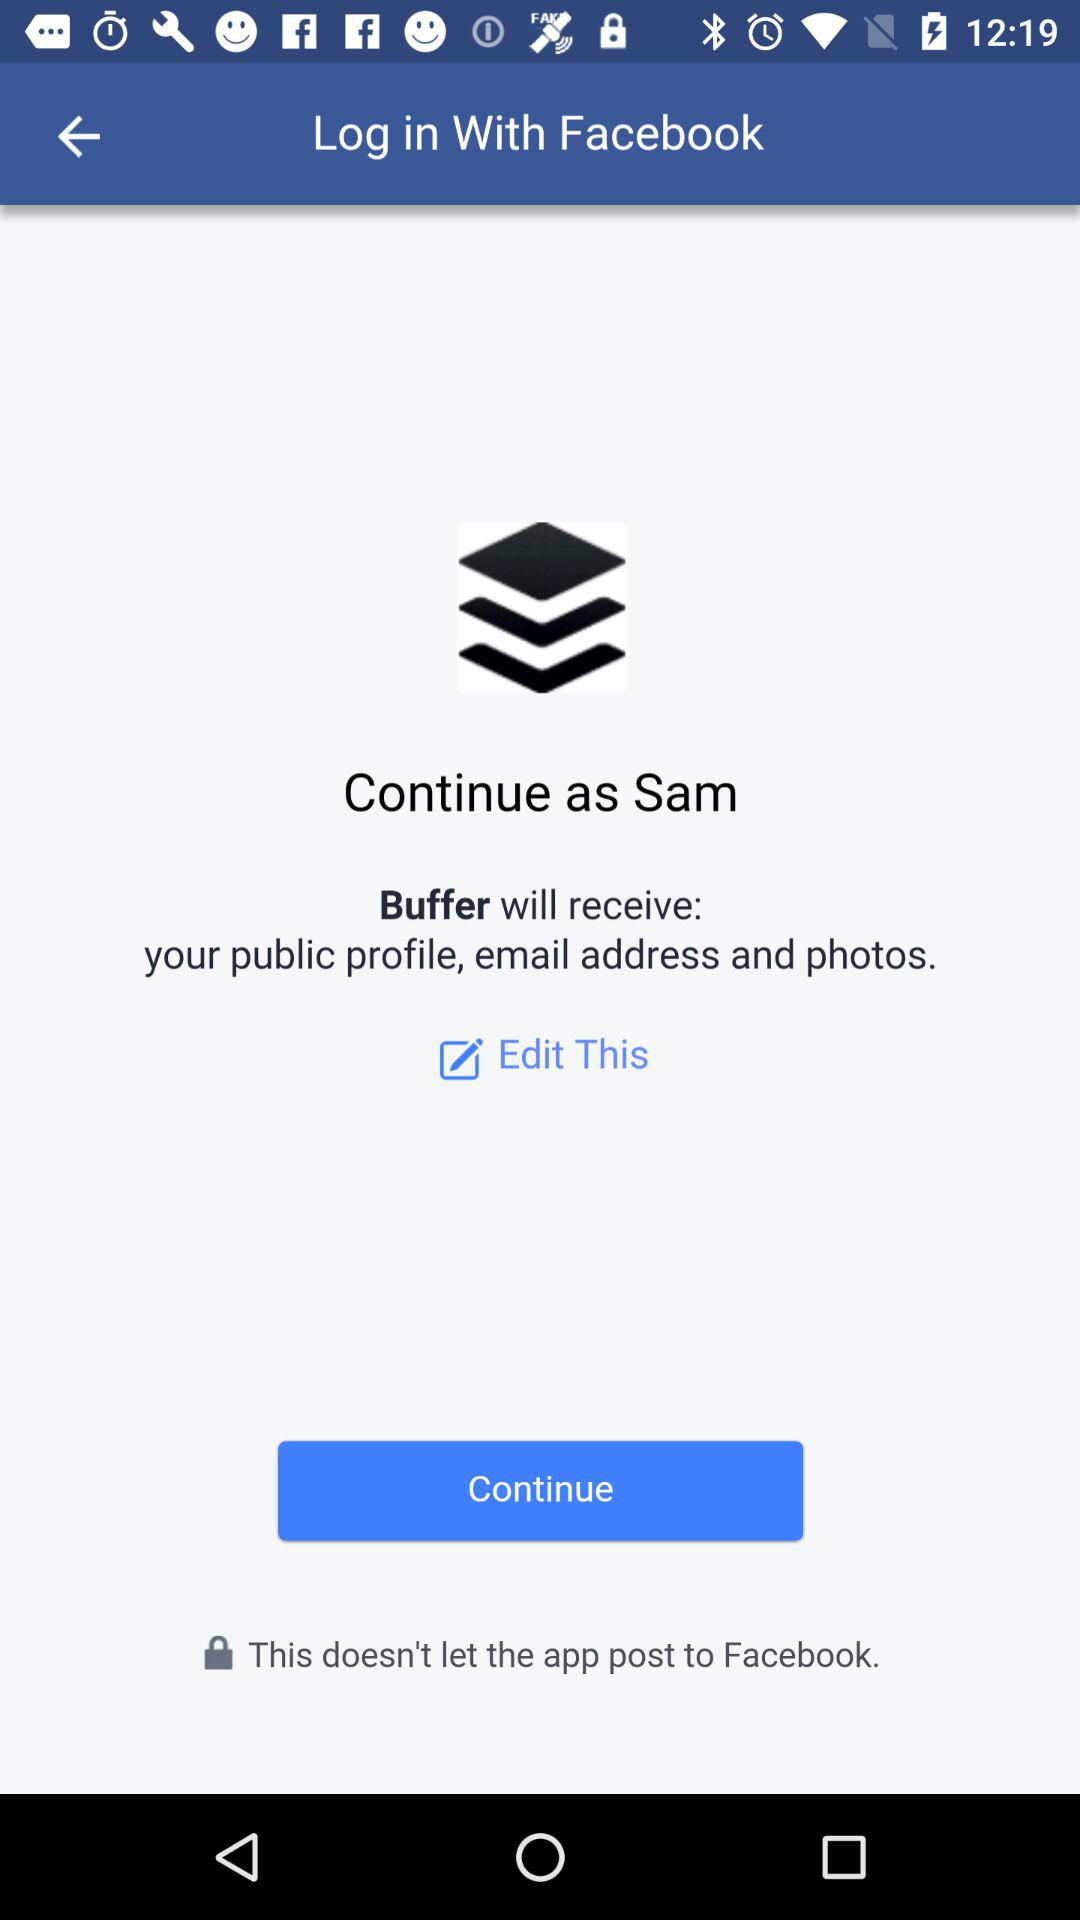What is the user name? The user name is Sam. 